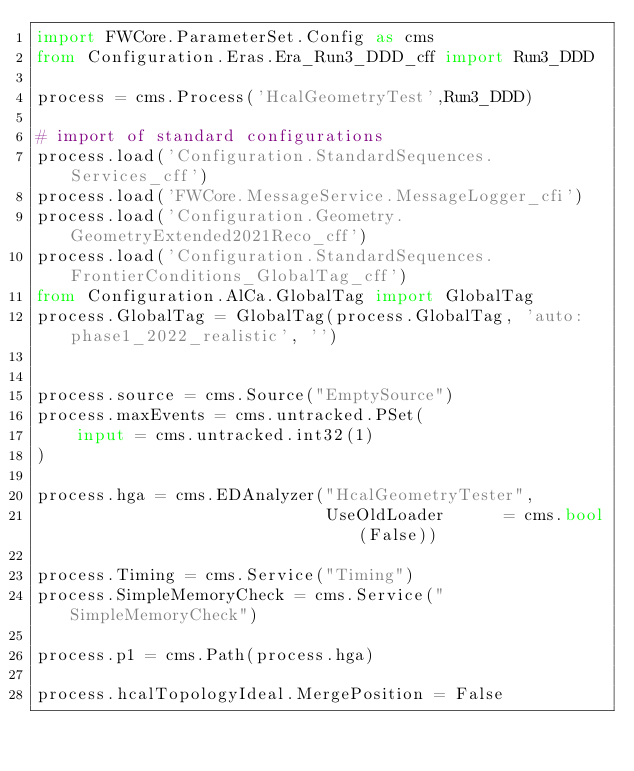<code> <loc_0><loc_0><loc_500><loc_500><_Python_>import FWCore.ParameterSet.Config as cms
from Configuration.Eras.Era_Run3_DDD_cff import Run3_DDD

process = cms.Process('HcalGeometryTest',Run3_DDD)

# import of standard configurations
process.load('Configuration.StandardSequences.Services_cff')
process.load('FWCore.MessageService.MessageLogger_cfi')
process.load('Configuration.Geometry.GeometryExtended2021Reco_cff')
process.load('Configuration.StandardSequences.FrontierConditions_GlobalTag_cff')
from Configuration.AlCa.GlobalTag import GlobalTag
process.GlobalTag = GlobalTag(process.GlobalTag, 'auto:phase1_2022_realistic', '')


process.source = cms.Source("EmptySource")
process.maxEvents = cms.untracked.PSet(
    input = cms.untracked.int32(1)
)

process.hga = cms.EDAnalyzer("HcalGeometryTester",
                             UseOldLoader      = cms.bool(False))

process.Timing = cms.Service("Timing")
process.SimpleMemoryCheck = cms.Service("SimpleMemoryCheck")

process.p1 = cms.Path(process.hga)

process.hcalTopologyIdeal.MergePosition = False
</code> 